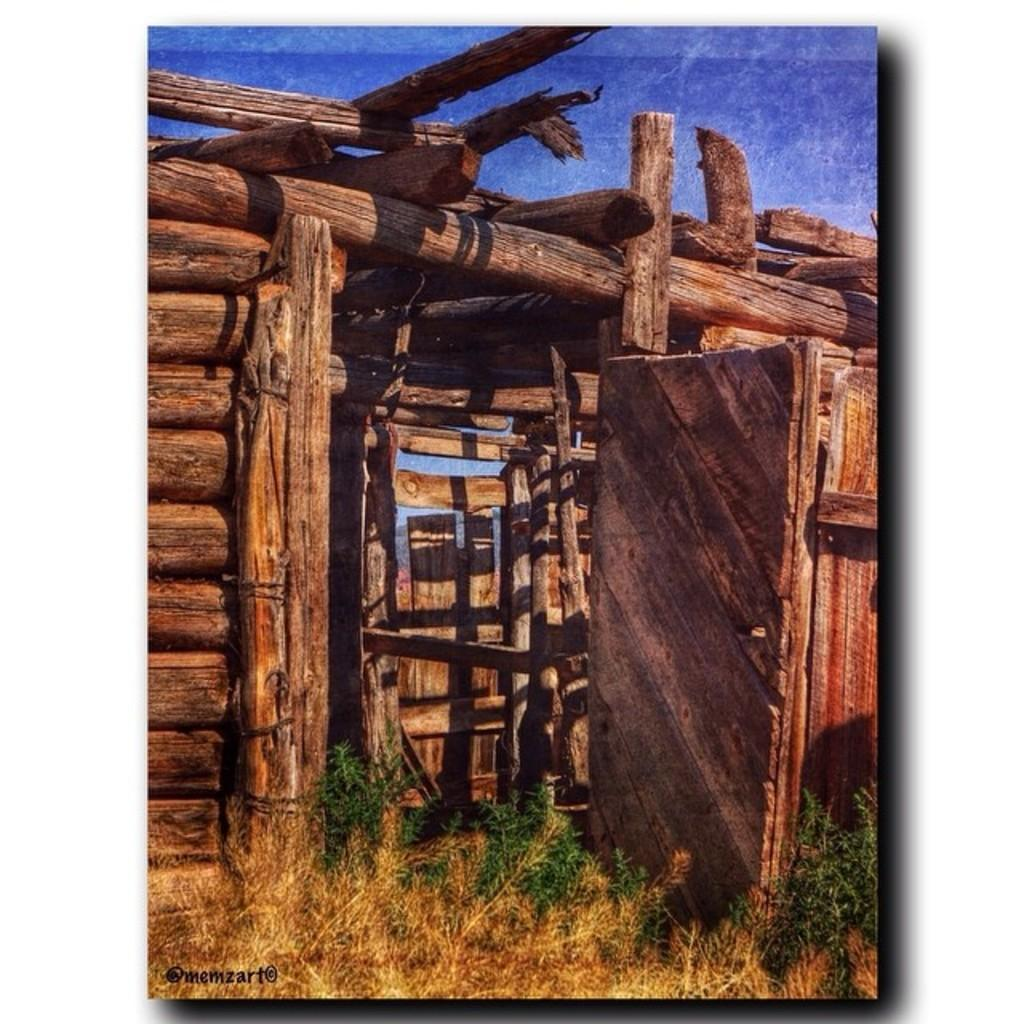What type of structure is visible in the image? There is a cabin in the image. What material is the cabin made of? The cabin is made of wood. How does the cabin appear in terms of its structure? The cabin has a frame-like appearance. What type of music is the band playing in the background of the image? There is no band present in the image, so it is not possible to determine what type of music might be playing. 